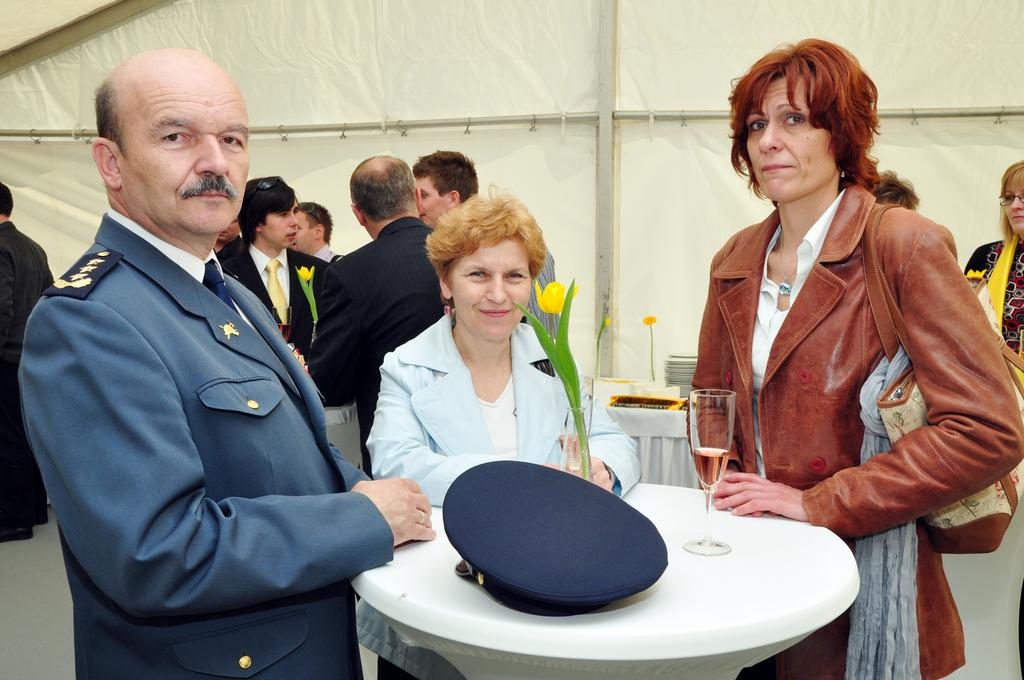How many people can be seen in the image? There are people in the image, but the exact number cannot be determined from the provided facts. What type of furniture is present in the image? There are tables in the image. What is placed on the table? A cap, a flower vase, and a glass are placed on the table. What can be seen in the background of the image? There is a tent in the background of the image. What color is the orange on the table in the image? There is no orange present on the table in the image. What type of sound can be heard coming from the tent in the image? The image is static, so no sounds can be heard. Is there a cobweb visible on the tent in the image? The presence of a cobweb is not mentioned in the provided facts, so it cannot be determined from the image. 